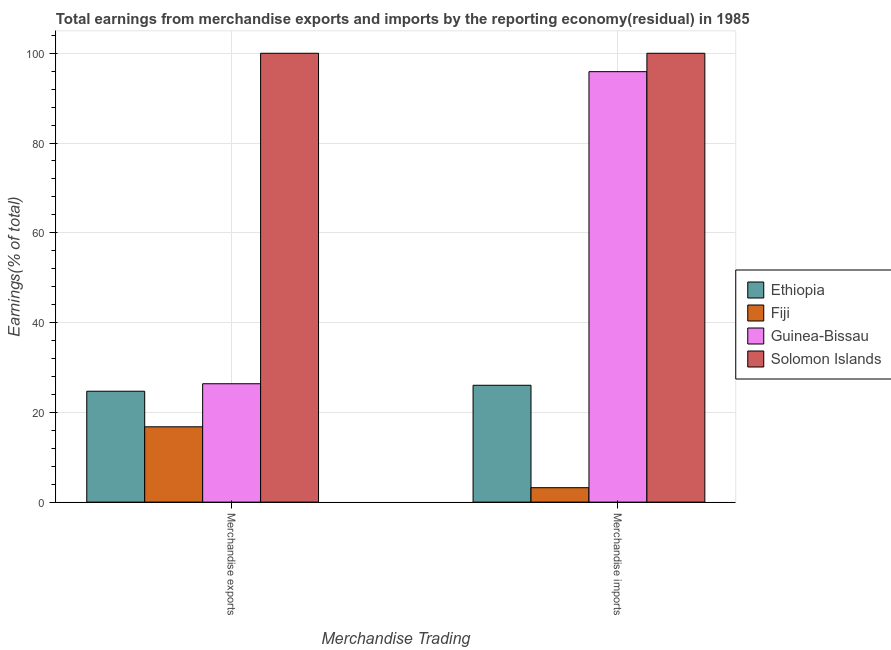Are the number of bars on each tick of the X-axis equal?
Your response must be concise. Yes. How many bars are there on the 2nd tick from the right?
Provide a succinct answer. 4. What is the label of the 1st group of bars from the left?
Give a very brief answer. Merchandise exports. What is the earnings from merchandise imports in Guinea-Bissau?
Ensure brevity in your answer.  95.9. Across all countries, what is the minimum earnings from merchandise imports?
Your answer should be very brief. 3.22. In which country was the earnings from merchandise imports maximum?
Your response must be concise. Solomon Islands. In which country was the earnings from merchandise imports minimum?
Provide a short and direct response. Fiji. What is the total earnings from merchandise exports in the graph?
Ensure brevity in your answer.  167.86. What is the difference between the earnings from merchandise exports in Solomon Islands and that in Fiji?
Your answer should be very brief. 83.22. What is the difference between the earnings from merchandise exports in Solomon Islands and the earnings from merchandise imports in Ethiopia?
Offer a very short reply. 73.97. What is the average earnings from merchandise exports per country?
Your answer should be compact. 41.97. What is the difference between the earnings from merchandise exports and earnings from merchandise imports in Solomon Islands?
Your response must be concise. 0. In how many countries, is the earnings from merchandise exports greater than 64 %?
Your answer should be compact. 1. What is the ratio of the earnings from merchandise exports in Ethiopia to that in Solomon Islands?
Your response must be concise. 0.25. What does the 2nd bar from the left in Merchandise exports represents?
Ensure brevity in your answer.  Fiji. What does the 3rd bar from the right in Merchandise exports represents?
Keep it short and to the point. Fiji. Are the values on the major ticks of Y-axis written in scientific E-notation?
Offer a very short reply. No. Does the graph contain any zero values?
Offer a terse response. No. Does the graph contain grids?
Provide a short and direct response. Yes. Where does the legend appear in the graph?
Your answer should be compact. Center right. What is the title of the graph?
Make the answer very short. Total earnings from merchandise exports and imports by the reporting economy(residual) in 1985. Does "Mali" appear as one of the legend labels in the graph?
Offer a very short reply. No. What is the label or title of the X-axis?
Your answer should be very brief. Merchandise Trading. What is the label or title of the Y-axis?
Ensure brevity in your answer.  Earnings(% of total). What is the Earnings(% of total) of Ethiopia in Merchandise exports?
Your answer should be very brief. 24.71. What is the Earnings(% of total) in Fiji in Merchandise exports?
Keep it short and to the point. 16.78. What is the Earnings(% of total) in Guinea-Bissau in Merchandise exports?
Offer a very short reply. 26.37. What is the Earnings(% of total) in Solomon Islands in Merchandise exports?
Make the answer very short. 100. What is the Earnings(% of total) of Ethiopia in Merchandise imports?
Offer a very short reply. 26.03. What is the Earnings(% of total) in Fiji in Merchandise imports?
Offer a terse response. 3.22. What is the Earnings(% of total) in Guinea-Bissau in Merchandise imports?
Ensure brevity in your answer.  95.9. Across all Merchandise Trading, what is the maximum Earnings(% of total) in Ethiopia?
Your answer should be compact. 26.03. Across all Merchandise Trading, what is the maximum Earnings(% of total) in Fiji?
Keep it short and to the point. 16.78. Across all Merchandise Trading, what is the maximum Earnings(% of total) in Guinea-Bissau?
Your response must be concise. 95.9. Across all Merchandise Trading, what is the maximum Earnings(% of total) in Solomon Islands?
Give a very brief answer. 100. Across all Merchandise Trading, what is the minimum Earnings(% of total) in Ethiopia?
Provide a short and direct response. 24.71. Across all Merchandise Trading, what is the minimum Earnings(% of total) of Fiji?
Provide a succinct answer. 3.22. Across all Merchandise Trading, what is the minimum Earnings(% of total) of Guinea-Bissau?
Provide a succinct answer. 26.37. What is the total Earnings(% of total) of Ethiopia in the graph?
Offer a terse response. 50.74. What is the total Earnings(% of total) in Fiji in the graph?
Provide a short and direct response. 19.99. What is the total Earnings(% of total) of Guinea-Bissau in the graph?
Keep it short and to the point. 122.28. What is the difference between the Earnings(% of total) in Ethiopia in Merchandise exports and that in Merchandise imports?
Offer a very short reply. -1.32. What is the difference between the Earnings(% of total) of Fiji in Merchandise exports and that in Merchandise imports?
Give a very brief answer. 13.56. What is the difference between the Earnings(% of total) of Guinea-Bissau in Merchandise exports and that in Merchandise imports?
Offer a terse response. -69.53. What is the difference between the Earnings(% of total) of Solomon Islands in Merchandise exports and that in Merchandise imports?
Give a very brief answer. 0. What is the difference between the Earnings(% of total) in Ethiopia in Merchandise exports and the Earnings(% of total) in Fiji in Merchandise imports?
Your answer should be very brief. 21.49. What is the difference between the Earnings(% of total) of Ethiopia in Merchandise exports and the Earnings(% of total) of Guinea-Bissau in Merchandise imports?
Keep it short and to the point. -71.19. What is the difference between the Earnings(% of total) in Ethiopia in Merchandise exports and the Earnings(% of total) in Solomon Islands in Merchandise imports?
Keep it short and to the point. -75.29. What is the difference between the Earnings(% of total) of Fiji in Merchandise exports and the Earnings(% of total) of Guinea-Bissau in Merchandise imports?
Make the answer very short. -79.12. What is the difference between the Earnings(% of total) of Fiji in Merchandise exports and the Earnings(% of total) of Solomon Islands in Merchandise imports?
Offer a terse response. -83.22. What is the difference between the Earnings(% of total) of Guinea-Bissau in Merchandise exports and the Earnings(% of total) of Solomon Islands in Merchandise imports?
Make the answer very short. -73.63. What is the average Earnings(% of total) of Ethiopia per Merchandise Trading?
Give a very brief answer. 25.37. What is the average Earnings(% of total) in Fiji per Merchandise Trading?
Your response must be concise. 10. What is the average Earnings(% of total) in Guinea-Bissau per Merchandise Trading?
Your answer should be compact. 61.14. What is the difference between the Earnings(% of total) in Ethiopia and Earnings(% of total) in Fiji in Merchandise exports?
Offer a terse response. 7.93. What is the difference between the Earnings(% of total) of Ethiopia and Earnings(% of total) of Guinea-Bissau in Merchandise exports?
Offer a terse response. -1.67. What is the difference between the Earnings(% of total) in Ethiopia and Earnings(% of total) in Solomon Islands in Merchandise exports?
Keep it short and to the point. -75.29. What is the difference between the Earnings(% of total) in Fiji and Earnings(% of total) in Guinea-Bissau in Merchandise exports?
Give a very brief answer. -9.6. What is the difference between the Earnings(% of total) of Fiji and Earnings(% of total) of Solomon Islands in Merchandise exports?
Give a very brief answer. -83.22. What is the difference between the Earnings(% of total) in Guinea-Bissau and Earnings(% of total) in Solomon Islands in Merchandise exports?
Provide a succinct answer. -73.63. What is the difference between the Earnings(% of total) of Ethiopia and Earnings(% of total) of Fiji in Merchandise imports?
Offer a very short reply. 22.82. What is the difference between the Earnings(% of total) of Ethiopia and Earnings(% of total) of Guinea-Bissau in Merchandise imports?
Your response must be concise. -69.87. What is the difference between the Earnings(% of total) in Ethiopia and Earnings(% of total) in Solomon Islands in Merchandise imports?
Your answer should be very brief. -73.97. What is the difference between the Earnings(% of total) in Fiji and Earnings(% of total) in Guinea-Bissau in Merchandise imports?
Your answer should be very brief. -92.68. What is the difference between the Earnings(% of total) of Fiji and Earnings(% of total) of Solomon Islands in Merchandise imports?
Your response must be concise. -96.78. What is the difference between the Earnings(% of total) of Guinea-Bissau and Earnings(% of total) of Solomon Islands in Merchandise imports?
Your answer should be very brief. -4.1. What is the ratio of the Earnings(% of total) of Ethiopia in Merchandise exports to that in Merchandise imports?
Offer a terse response. 0.95. What is the ratio of the Earnings(% of total) in Fiji in Merchandise exports to that in Merchandise imports?
Give a very brief answer. 5.22. What is the ratio of the Earnings(% of total) of Guinea-Bissau in Merchandise exports to that in Merchandise imports?
Provide a short and direct response. 0.28. What is the ratio of the Earnings(% of total) in Solomon Islands in Merchandise exports to that in Merchandise imports?
Your answer should be compact. 1. What is the difference between the highest and the second highest Earnings(% of total) of Ethiopia?
Your response must be concise. 1.32. What is the difference between the highest and the second highest Earnings(% of total) of Fiji?
Your answer should be compact. 13.56. What is the difference between the highest and the second highest Earnings(% of total) of Guinea-Bissau?
Give a very brief answer. 69.53. What is the difference between the highest and the second highest Earnings(% of total) of Solomon Islands?
Provide a short and direct response. 0. What is the difference between the highest and the lowest Earnings(% of total) in Ethiopia?
Offer a terse response. 1.32. What is the difference between the highest and the lowest Earnings(% of total) of Fiji?
Make the answer very short. 13.56. What is the difference between the highest and the lowest Earnings(% of total) in Guinea-Bissau?
Offer a terse response. 69.53. What is the difference between the highest and the lowest Earnings(% of total) of Solomon Islands?
Provide a succinct answer. 0. 